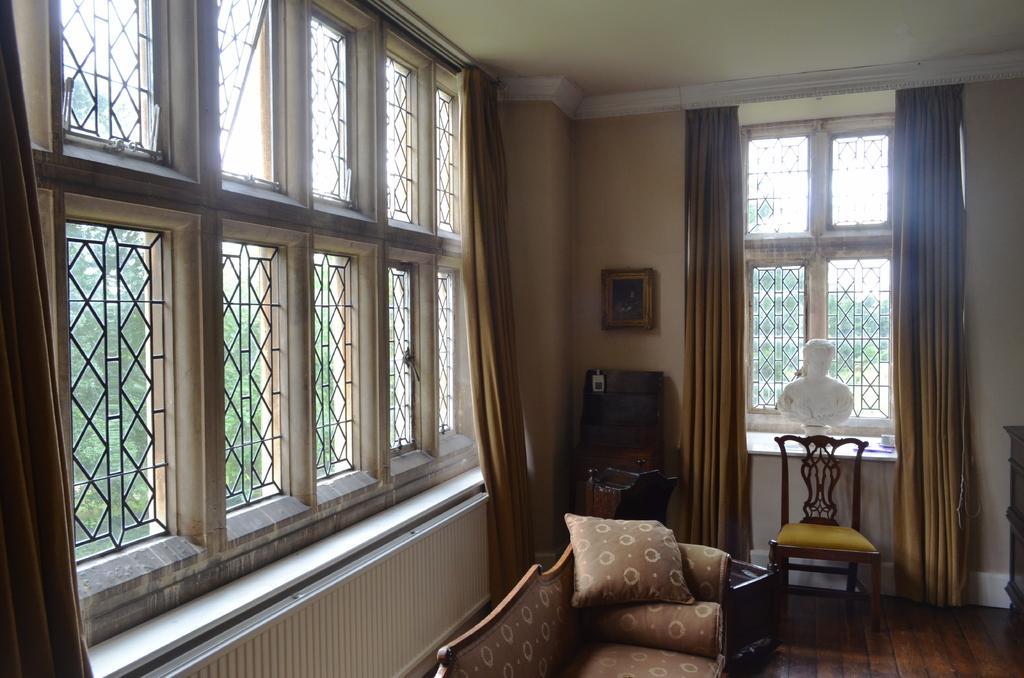Describe this image in one or two sentences. This is an inside view of a room. At the bottom there is a couch placed on the floor and there is a pillow on the couch. Beside there is a chair and a table on which a box is placed. Here I can see two windows to the wall and there are few curtains. In the background there is a frame attached to the wall. Through the windows we can see the outside view. In the outside there are many trees. 